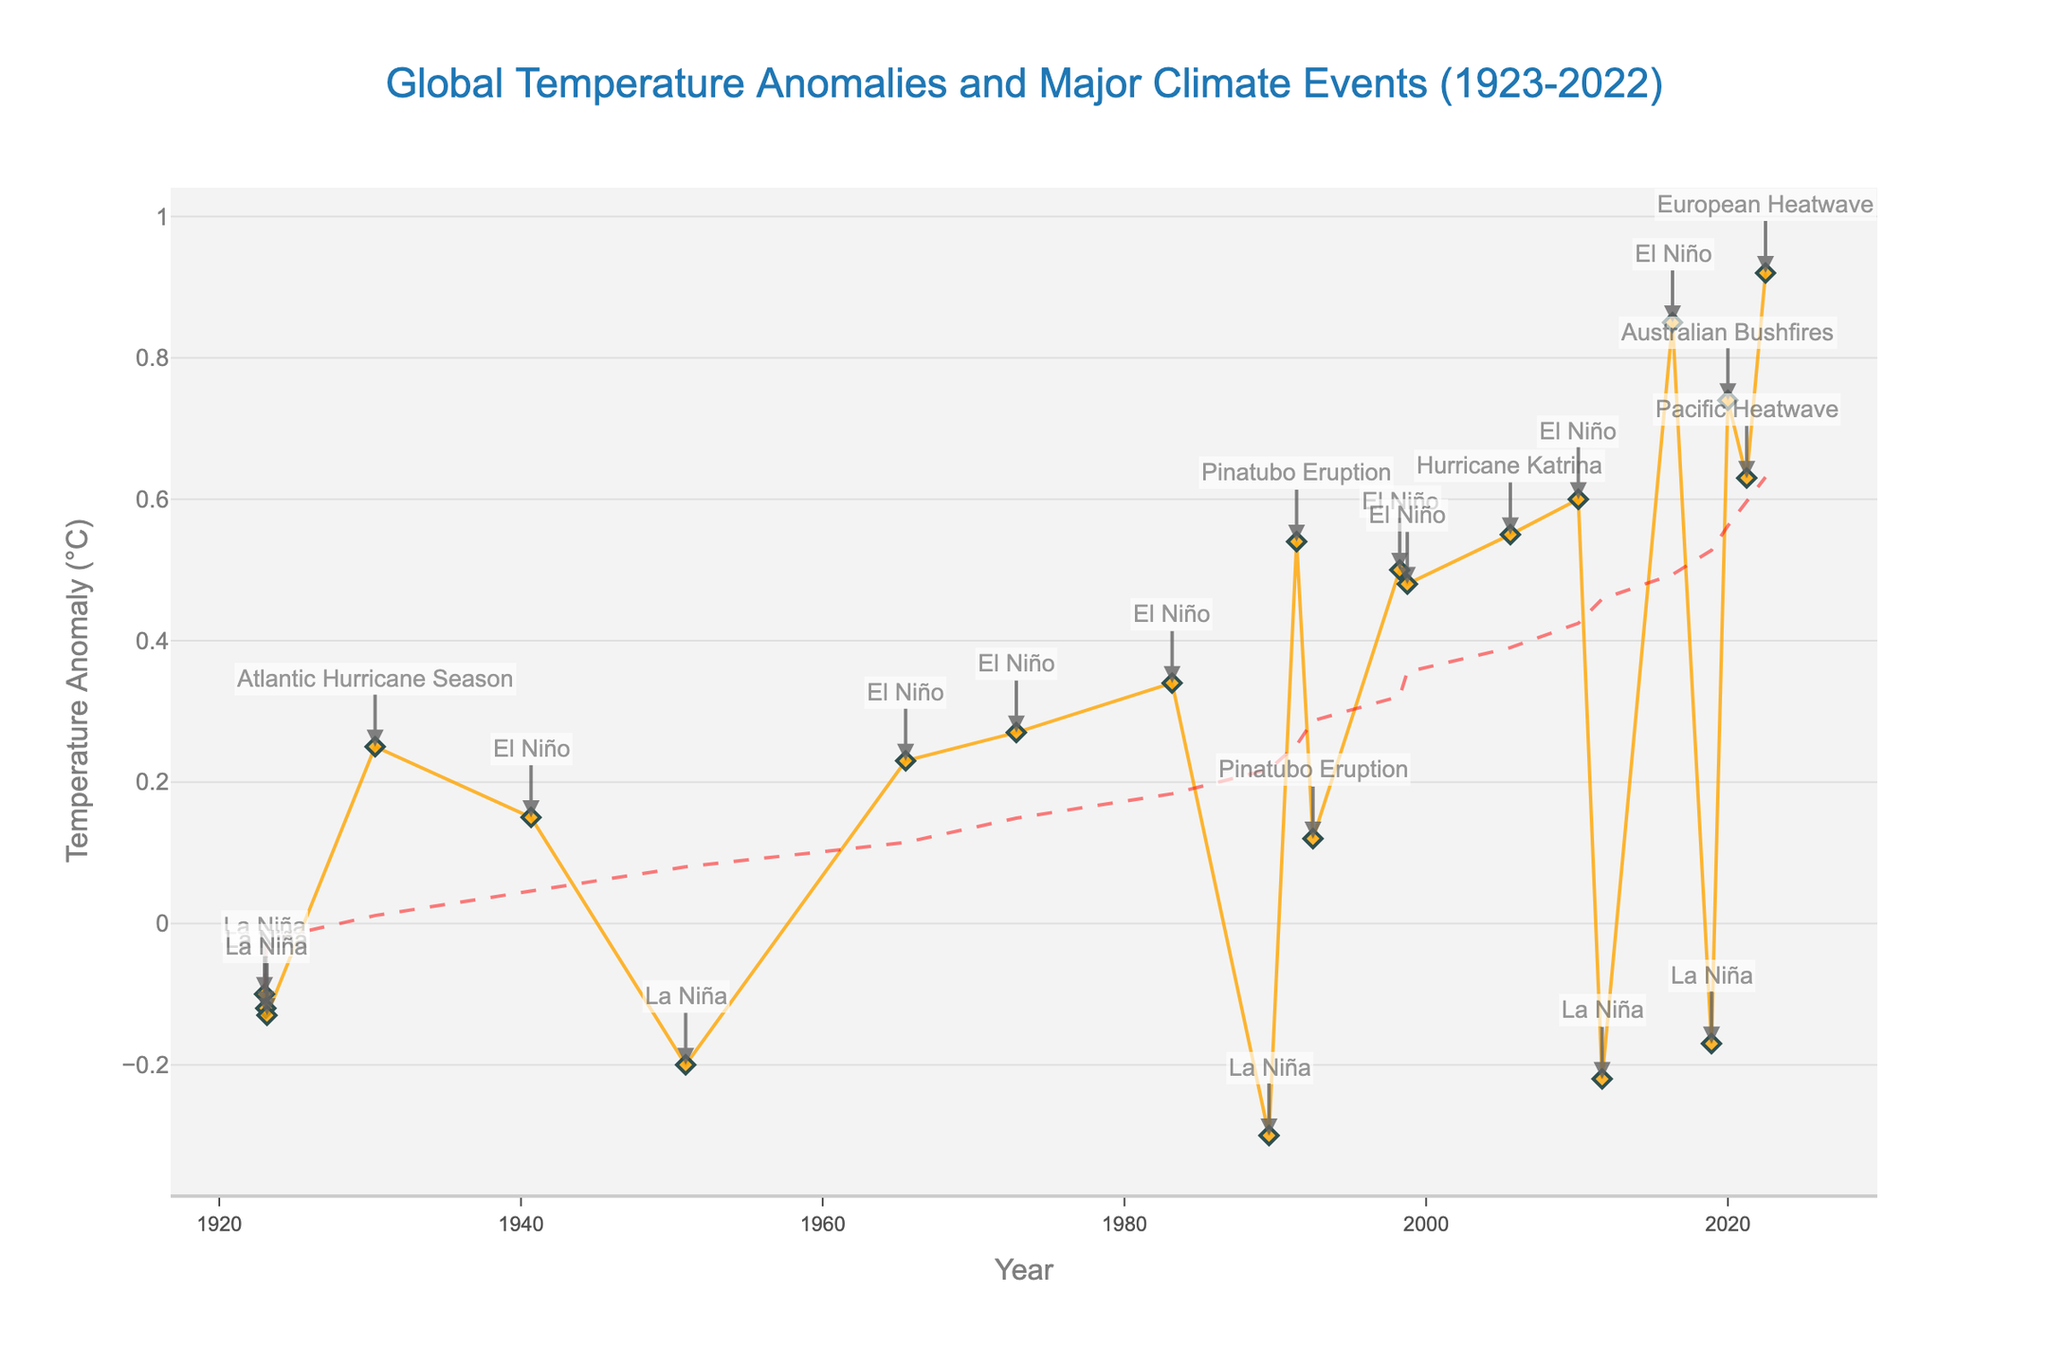what is the title of the figure? The title is written at the top center of the figure, indicating the main subject of the plot.
Answer: Global Temperature Anomalies and Major Climate Events (1923-2022) what are the x-axis and y-axis titles in the figure? The x-axis title is written horizontally along the bottom of the plot, indicating the variable shown on the x-axis. The y-axis title is vertically along the left side of the plot for the y-axis variable.
Answer: x-axis: Year, y-axis: Temperature Anomaly (°C) how many significant climate events are annotated in the figure? To find the number of major climate events, count the annotations that have a text associated with them pointing to specific data points.
Answer: 13 which climate event corresponds to the highest temperature anomaly? Observe the data points and annotations to find which climate event is noted at the highest y-value.
Answer: European Heatwave is there a general trend in temperature anomalies over the century, and how is it indicated in the plot? Look for a trend line in the plot, usually shown using a line of a different pattern or color than the main data points. Identify whether the line shows an increasing, decreasing, or stable trend over time.
Answer: An upward trend is shown by a dashed line 